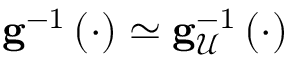Convert formula to latex. <formula><loc_0><loc_0><loc_500><loc_500>g ^ { - 1 } \left ( \cdot \right ) \simeq g _ { \mathcal { U } } ^ { - 1 } \left ( \cdot \right )</formula> 